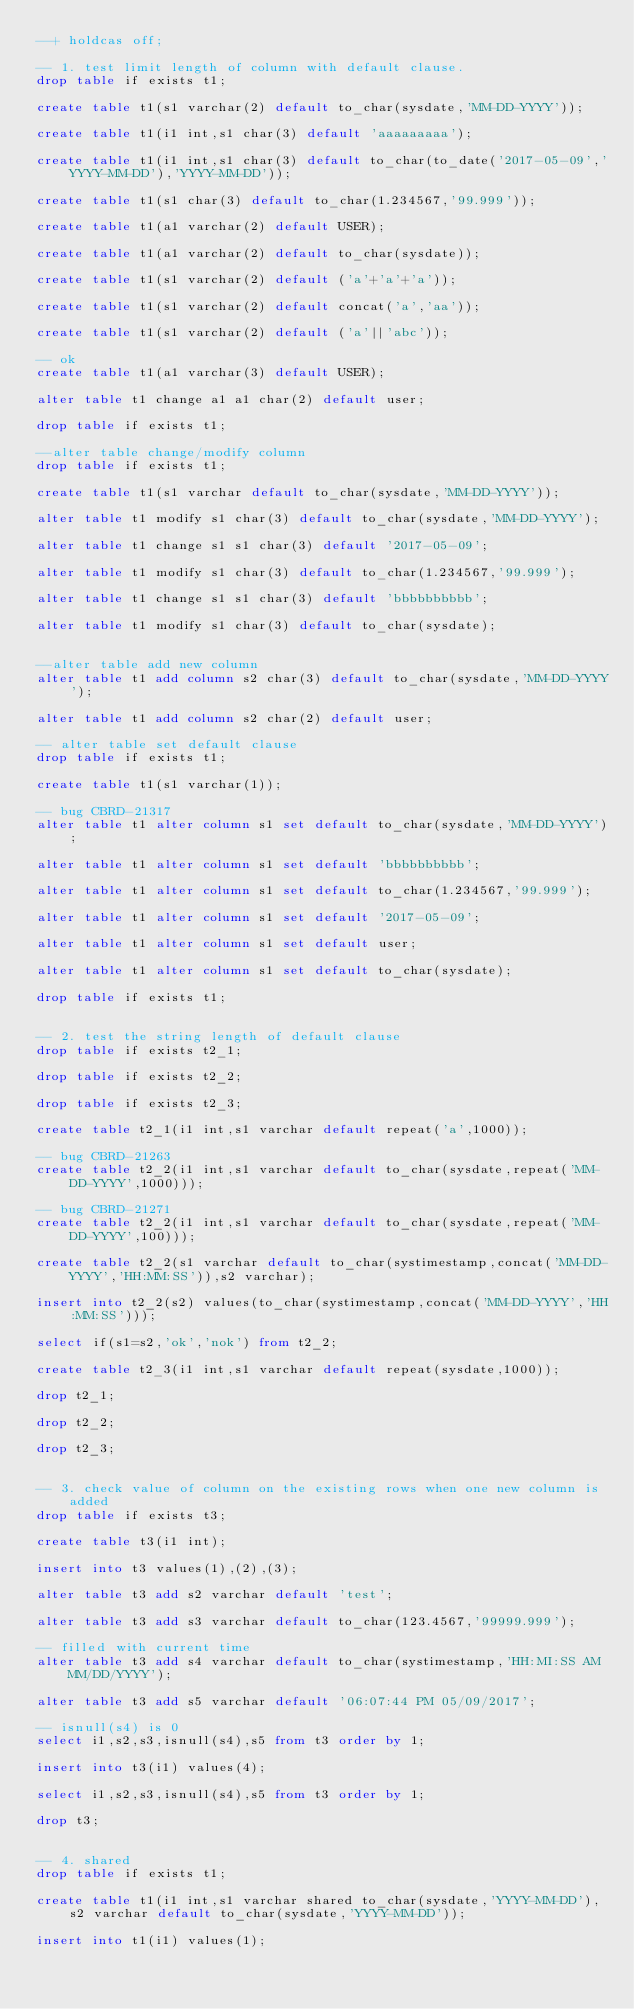Convert code to text. <code><loc_0><loc_0><loc_500><loc_500><_SQL_>--+ holdcas off;

-- 1. test limit length of column with default clause.
drop table if exists t1;

create table t1(s1 varchar(2) default to_char(sysdate,'MM-DD-YYYY'));

create table t1(i1 int,s1 char(3) default 'aaaaaaaaa');

create table t1(i1 int,s1 char(3) default to_char(to_date('2017-05-09','YYYY-MM-DD'),'YYYY-MM-DD'));

create table t1(s1 char(3) default to_char(1.234567,'99.999'));

create table t1(a1 varchar(2) default USER); 

create table t1(a1 varchar(2) default to_char(sysdate));

create table t1(s1 varchar(2) default ('a'+'a'+'a'));

create table t1(s1 varchar(2) default concat('a','aa'));

create table t1(s1 varchar(2) default ('a'||'abc'));

-- ok
create table t1(a1 varchar(3) default USER);

alter table t1 change a1 a1 char(2) default user;

drop table if exists t1;

--alter table change/modify column
drop table if exists t1;

create table t1(s1 varchar default to_char(sysdate,'MM-DD-YYYY'));

alter table t1 modify s1 char(3) default to_char(sysdate,'MM-DD-YYYY');

alter table t1 change s1 s1 char(3) default '2017-05-09'; 

alter table t1 modify s1 char(3) default to_char(1.234567,'99.999'); 

alter table t1 change s1 s1 char(3) default 'bbbbbbbbbb'; 

alter table t1 modify s1 char(3) default to_char(sysdate); 


--alter table add new column
alter table t1 add column s2 char(3) default to_char(sysdate,'MM-DD-YYYY');

alter table t1 add column s2 char(2) default user; 

-- alter table set default clause
drop table if exists t1;

create table t1(s1 varchar(1));

-- bug CBRD-21317
alter table t1 alter column s1 set default to_char(sysdate,'MM-DD-YYYY');

alter table t1 alter column s1 set default 'bbbbbbbbbb';

alter table t1 alter column s1 set default to_char(1.234567,'99.999');

alter table t1 alter column s1 set default '2017-05-09';

alter table t1 alter column s1 set default user;

alter table t1 alter column s1 set default to_char(sysdate);

drop table if exists t1;


-- 2. test the string length of default clause
drop table if exists t2_1;

drop table if exists t2_2;

drop table if exists t2_3;

create table t2_1(i1 int,s1 varchar default repeat('a',1000));

-- bug CBRD-21263
create table t2_2(i1 int,s1 varchar default to_char(sysdate,repeat('MM-DD-YYYY',1000)));

-- bug CBRD-21271
create table t2_2(i1 int,s1 varchar default to_char(sysdate,repeat('MM-DD-YYYY',100)));

create table t2_2(s1 varchar default to_char(systimestamp,concat('MM-DD-YYYY','HH:MM:SS')),s2 varchar);

insert into t2_2(s2) values(to_char(systimestamp,concat('MM-DD-YYYY','HH:MM:SS')));

select if(s1=s2,'ok','nok') from t2_2;

create table t2_3(i1 int,s1 varchar default repeat(sysdate,1000)); 

drop t2_1;

drop t2_2;

drop t2_3;


-- 3. check value of column on the existing rows when one new column is added
drop table if exists t3;

create table t3(i1 int);

insert into t3 values(1),(2),(3);

alter table t3 add s2 varchar default 'test';

alter table t3 add s3 varchar default to_char(123.4567,'99999.999');

-- filled with current time
alter table t3 add s4 varchar default to_char(systimestamp,'HH:MI:SS AM MM/DD/YYYY');

alter table t3 add s5 varchar default '06:07:44 PM 05/09/2017';

-- isnull(s4) is 0
select i1,s2,s3,isnull(s4),s5 from t3 order by 1; 

insert into t3(i1) values(4);

select i1,s2,s3,isnull(s4),s5 from t3 order by 1; 

drop t3;


-- 4. shared
drop table if exists t1;

create table t1(i1 int,s1 varchar shared to_char(sysdate,'YYYY-MM-DD'),s2 varchar default to_char(sysdate,'YYYY-MM-DD')); 

insert into t1(i1) values(1);
</code> 